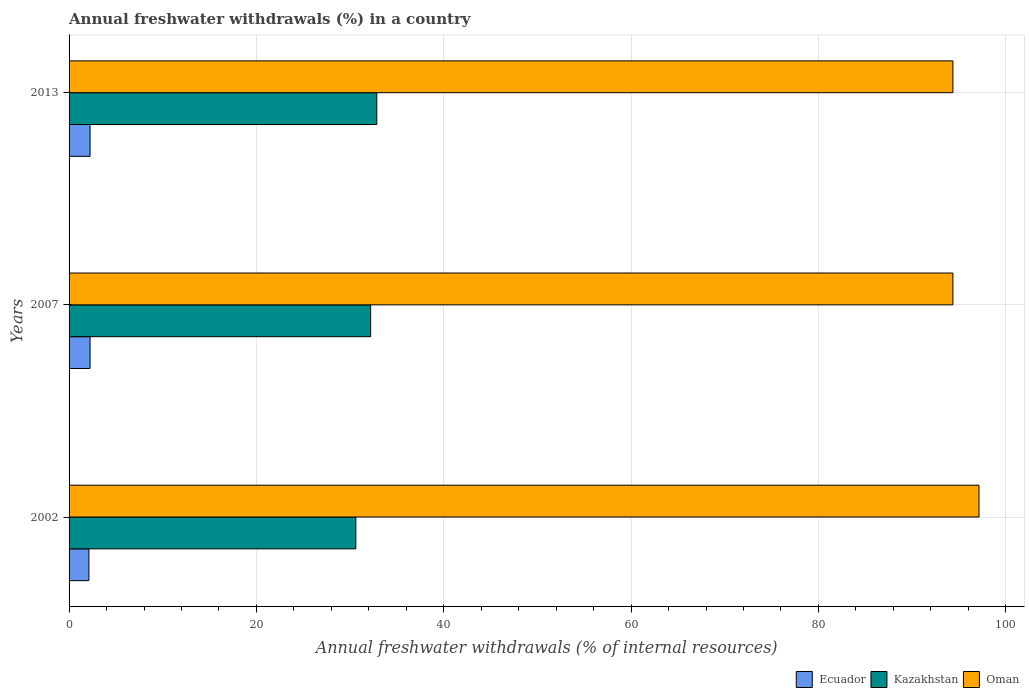How many different coloured bars are there?
Offer a very short reply. 3. Are the number of bars on each tick of the Y-axis equal?
Keep it short and to the point. Yes. How many bars are there on the 3rd tick from the bottom?
Your answer should be very brief. 3. What is the label of the 2nd group of bars from the top?
Your answer should be very brief. 2007. In how many cases, is the number of bars for a given year not equal to the number of legend labels?
Provide a succinct answer. 0. What is the percentage of annual freshwater withdrawals in Oman in 2002?
Offer a terse response. 97.14. Across all years, what is the maximum percentage of annual freshwater withdrawals in Oman?
Keep it short and to the point. 97.14. Across all years, what is the minimum percentage of annual freshwater withdrawals in Kazakhstan?
Provide a short and direct response. 30.61. In which year was the percentage of annual freshwater withdrawals in Ecuador maximum?
Your answer should be very brief. 2007. In which year was the percentage of annual freshwater withdrawals in Oman minimum?
Give a very brief answer. 2007. What is the total percentage of annual freshwater withdrawals in Oman in the graph?
Your response must be concise. 285.86. What is the difference between the percentage of annual freshwater withdrawals in Kazakhstan in 2002 and that in 2007?
Offer a terse response. -1.59. What is the difference between the percentage of annual freshwater withdrawals in Kazakhstan in 2007 and the percentage of annual freshwater withdrawals in Ecuador in 2013?
Provide a succinct answer. 29.96. What is the average percentage of annual freshwater withdrawals in Ecuador per year?
Ensure brevity in your answer.  2.2. In the year 2007, what is the difference between the percentage of annual freshwater withdrawals in Oman and percentage of annual freshwater withdrawals in Kazakhstan?
Ensure brevity in your answer.  62.16. What is the ratio of the percentage of annual freshwater withdrawals in Oman in 2002 to that in 2013?
Provide a succinct answer. 1.03. Is the percentage of annual freshwater withdrawals in Ecuador in 2007 less than that in 2013?
Provide a succinct answer. No. Is the difference between the percentage of annual freshwater withdrawals in Oman in 2007 and 2013 greater than the difference between the percentage of annual freshwater withdrawals in Kazakhstan in 2007 and 2013?
Your answer should be compact. Yes. What is the difference between the highest and the second highest percentage of annual freshwater withdrawals in Oman?
Ensure brevity in your answer.  2.79. What is the difference between the highest and the lowest percentage of annual freshwater withdrawals in Ecuador?
Ensure brevity in your answer.  0.12. Is the sum of the percentage of annual freshwater withdrawals in Oman in 2007 and 2013 greater than the maximum percentage of annual freshwater withdrawals in Kazakhstan across all years?
Your answer should be compact. Yes. What does the 2nd bar from the top in 2013 represents?
Make the answer very short. Kazakhstan. What does the 3rd bar from the bottom in 2013 represents?
Make the answer very short. Oman. Does the graph contain any zero values?
Provide a short and direct response. No. Does the graph contain grids?
Offer a very short reply. Yes. What is the title of the graph?
Provide a succinct answer. Annual freshwater withdrawals (%) in a country. Does "Italy" appear as one of the legend labels in the graph?
Offer a terse response. No. What is the label or title of the X-axis?
Ensure brevity in your answer.  Annual freshwater withdrawals (% of internal resources). What is the Annual freshwater withdrawals (% of internal resources) of Ecuador in 2002?
Your answer should be very brief. 2.12. What is the Annual freshwater withdrawals (% of internal resources) in Kazakhstan in 2002?
Provide a short and direct response. 30.61. What is the Annual freshwater withdrawals (% of internal resources) in Oman in 2002?
Your answer should be compact. 97.14. What is the Annual freshwater withdrawals (% of internal resources) of Ecuador in 2007?
Provide a short and direct response. 2.24. What is the Annual freshwater withdrawals (% of internal resources) in Kazakhstan in 2007?
Offer a very short reply. 32.2. What is the Annual freshwater withdrawals (% of internal resources) in Oman in 2007?
Ensure brevity in your answer.  94.36. What is the Annual freshwater withdrawals (% of internal resources) of Ecuador in 2013?
Provide a short and direct response. 2.24. What is the Annual freshwater withdrawals (% of internal resources) of Kazakhstan in 2013?
Give a very brief answer. 32.85. What is the Annual freshwater withdrawals (% of internal resources) in Oman in 2013?
Provide a short and direct response. 94.36. Across all years, what is the maximum Annual freshwater withdrawals (% of internal resources) of Ecuador?
Ensure brevity in your answer.  2.24. Across all years, what is the maximum Annual freshwater withdrawals (% of internal resources) of Kazakhstan?
Your response must be concise. 32.85. Across all years, what is the maximum Annual freshwater withdrawals (% of internal resources) of Oman?
Ensure brevity in your answer.  97.14. Across all years, what is the minimum Annual freshwater withdrawals (% of internal resources) of Ecuador?
Your response must be concise. 2.12. Across all years, what is the minimum Annual freshwater withdrawals (% of internal resources) of Kazakhstan?
Provide a succinct answer. 30.61. Across all years, what is the minimum Annual freshwater withdrawals (% of internal resources) of Oman?
Give a very brief answer. 94.36. What is the total Annual freshwater withdrawals (% of internal resources) in Ecuador in the graph?
Give a very brief answer. 6.6. What is the total Annual freshwater withdrawals (% of internal resources) in Kazakhstan in the graph?
Your answer should be very brief. 95.66. What is the total Annual freshwater withdrawals (% of internal resources) in Oman in the graph?
Make the answer very short. 285.86. What is the difference between the Annual freshwater withdrawals (% of internal resources) of Ecuador in 2002 and that in 2007?
Ensure brevity in your answer.  -0.12. What is the difference between the Annual freshwater withdrawals (% of internal resources) in Kazakhstan in 2002 and that in 2007?
Ensure brevity in your answer.  -1.59. What is the difference between the Annual freshwater withdrawals (% of internal resources) in Oman in 2002 and that in 2007?
Your answer should be very brief. 2.79. What is the difference between the Annual freshwater withdrawals (% of internal resources) of Ecuador in 2002 and that in 2013?
Give a very brief answer. -0.12. What is the difference between the Annual freshwater withdrawals (% of internal resources) in Kazakhstan in 2002 and that in 2013?
Offer a terse response. -2.24. What is the difference between the Annual freshwater withdrawals (% of internal resources) in Oman in 2002 and that in 2013?
Keep it short and to the point. 2.79. What is the difference between the Annual freshwater withdrawals (% of internal resources) in Ecuador in 2007 and that in 2013?
Provide a succinct answer. 0. What is the difference between the Annual freshwater withdrawals (% of internal resources) in Kazakhstan in 2007 and that in 2013?
Offer a terse response. -0.65. What is the difference between the Annual freshwater withdrawals (% of internal resources) in Ecuador in 2002 and the Annual freshwater withdrawals (% of internal resources) in Kazakhstan in 2007?
Make the answer very short. -30.08. What is the difference between the Annual freshwater withdrawals (% of internal resources) in Ecuador in 2002 and the Annual freshwater withdrawals (% of internal resources) in Oman in 2007?
Provide a succinct answer. -92.24. What is the difference between the Annual freshwater withdrawals (% of internal resources) of Kazakhstan in 2002 and the Annual freshwater withdrawals (% of internal resources) of Oman in 2007?
Your answer should be compact. -63.74. What is the difference between the Annual freshwater withdrawals (% of internal resources) of Ecuador in 2002 and the Annual freshwater withdrawals (% of internal resources) of Kazakhstan in 2013?
Provide a succinct answer. -30.73. What is the difference between the Annual freshwater withdrawals (% of internal resources) in Ecuador in 2002 and the Annual freshwater withdrawals (% of internal resources) in Oman in 2013?
Your answer should be very brief. -92.24. What is the difference between the Annual freshwater withdrawals (% of internal resources) of Kazakhstan in 2002 and the Annual freshwater withdrawals (% of internal resources) of Oman in 2013?
Your response must be concise. -63.74. What is the difference between the Annual freshwater withdrawals (% of internal resources) of Ecuador in 2007 and the Annual freshwater withdrawals (% of internal resources) of Kazakhstan in 2013?
Provide a short and direct response. -30.61. What is the difference between the Annual freshwater withdrawals (% of internal resources) of Ecuador in 2007 and the Annual freshwater withdrawals (% of internal resources) of Oman in 2013?
Offer a very short reply. -92.12. What is the difference between the Annual freshwater withdrawals (% of internal resources) in Kazakhstan in 2007 and the Annual freshwater withdrawals (% of internal resources) in Oman in 2013?
Keep it short and to the point. -62.16. What is the average Annual freshwater withdrawals (% of internal resources) of Ecuador per year?
Offer a very short reply. 2.2. What is the average Annual freshwater withdrawals (% of internal resources) in Kazakhstan per year?
Your answer should be compact. 31.89. What is the average Annual freshwater withdrawals (% of internal resources) of Oman per year?
Keep it short and to the point. 95.29. In the year 2002, what is the difference between the Annual freshwater withdrawals (% of internal resources) in Ecuador and Annual freshwater withdrawals (% of internal resources) in Kazakhstan?
Your answer should be very brief. -28.5. In the year 2002, what is the difference between the Annual freshwater withdrawals (% of internal resources) in Ecuador and Annual freshwater withdrawals (% of internal resources) in Oman?
Your answer should be compact. -95.03. In the year 2002, what is the difference between the Annual freshwater withdrawals (% of internal resources) of Kazakhstan and Annual freshwater withdrawals (% of internal resources) of Oman?
Your answer should be compact. -66.53. In the year 2007, what is the difference between the Annual freshwater withdrawals (% of internal resources) in Ecuador and Annual freshwater withdrawals (% of internal resources) in Kazakhstan?
Offer a terse response. -29.96. In the year 2007, what is the difference between the Annual freshwater withdrawals (% of internal resources) in Ecuador and Annual freshwater withdrawals (% of internal resources) in Oman?
Make the answer very short. -92.12. In the year 2007, what is the difference between the Annual freshwater withdrawals (% of internal resources) in Kazakhstan and Annual freshwater withdrawals (% of internal resources) in Oman?
Offer a very short reply. -62.16. In the year 2013, what is the difference between the Annual freshwater withdrawals (% of internal resources) in Ecuador and Annual freshwater withdrawals (% of internal resources) in Kazakhstan?
Give a very brief answer. -30.61. In the year 2013, what is the difference between the Annual freshwater withdrawals (% of internal resources) of Ecuador and Annual freshwater withdrawals (% of internal resources) of Oman?
Provide a short and direct response. -92.12. In the year 2013, what is the difference between the Annual freshwater withdrawals (% of internal resources) of Kazakhstan and Annual freshwater withdrawals (% of internal resources) of Oman?
Your answer should be compact. -61.51. What is the ratio of the Annual freshwater withdrawals (% of internal resources) in Ecuador in 2002 to that in 2007?
Make the answer very short. 0.94. What is the ratio of the Annual freshwater withdrawals (% of internal resources) of Kazakhstan in 2002 to that in 2007?
Offer a terse response. 0.95. What is the ratio of the Annual freshwater withdrawals (% of internal resources) of Oman in 2002 to that in 2007?
Ensure brevity in your answer.  1.03. What is the ratio of the Annual freshwater withdrawals (% of internal resources) of Ecuador in 2002 to that in 2013?
Provide a succinct answer. 0.94. What is the ratio of the Annual freshwater withdrawals (% of internal resources) of Kazakhstan in 2002 to that in 2013?
Ensure brevity in your answer.  0.93. What is the ratio of the Annual freshwater withdrawals (% of internal resources) of Oman in 2002 to that in 2013?
Provide a short and direct response. 1.03. What is the ratio of the Annual freshwater withdrawals (% of internal resources) in Kazakhstan in 2007 to that in 2013?
Keep it short and to the point. 0.98. What is the difference between the highest and the second highest Annual freshwater withdrawals (% of internal resources) in Ecuador?
Offer a very short reply. 0. What is the difference between the highest and the second highest Annual freshwater withdrawals (% of internal resources) of Kazakhstan?
Offer a very short reply. 0.65. What is the difference between the highest and the second highest Annual freshwater withdrawals (% of internal resources) in Oman?
Ensure brevity in your answer.  2.79. What is the difference between the highest and the lowest Annual freshwater withdrawals (% of internal resources) in Ecuador?
Provide a short and direct response. 0.12. What is the difference between the highest and the lowest Annual freshwater withdrawals (% of internal resources) in Kazakhstan?
Give a very brief answer. 2.24. What is the difference between the highest and the lowest Annual freshwater withdrawals (% of internal resources) in Oman?
Offer a terse response. 2.79. 